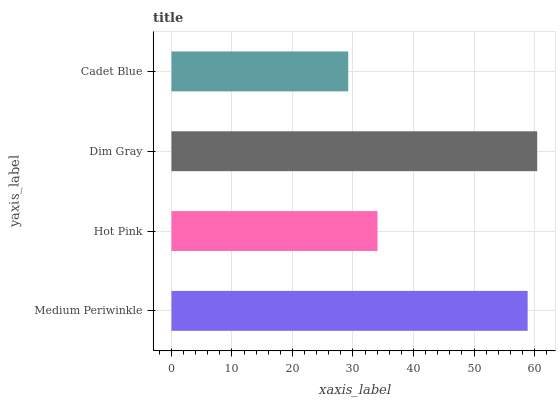Is Cadet Blue the minimum?
Answer yes or no. Yes. Is Dim Gray the maximum?
Answer yes or no. Yes. Is Hot Pink the minimum?
Answer yes or no. No. Is Hot Pink the maximum?
Answer yes or no. No. Is Medium Periwinkle greater than Hot Pink?
Answer yes or no. Yes. Is Hot Pink less than Medium Periwinkle?
Answer yes or no. Yes. Is Hot Pink greater than Medium Periwinkle?
Answer yes or no. No. Is Medium Periwinkle less than Hot Pink?
Answer yes or no. No. Is Medium Periwinkle the high median?
Answer yes or no. Yes. Is Hot Pink the low median?
Answer yes or no. Yes. Is Dim Gray the high median?
Answer yes or no. No. Is Dim Gray the low median?
Answer yes or no. No. 